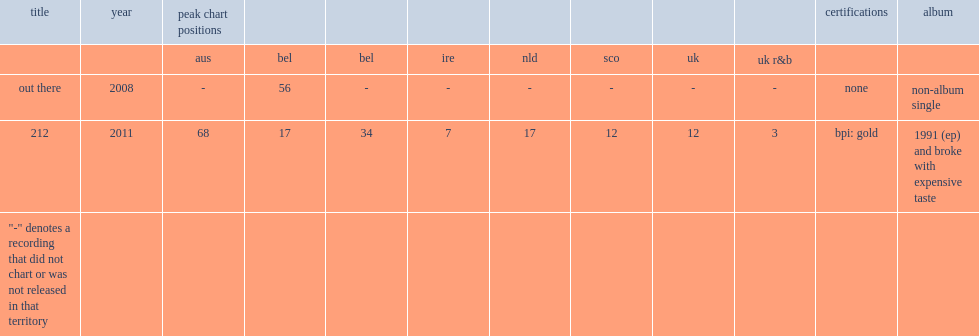When did the single 212 release? 2011.0. 